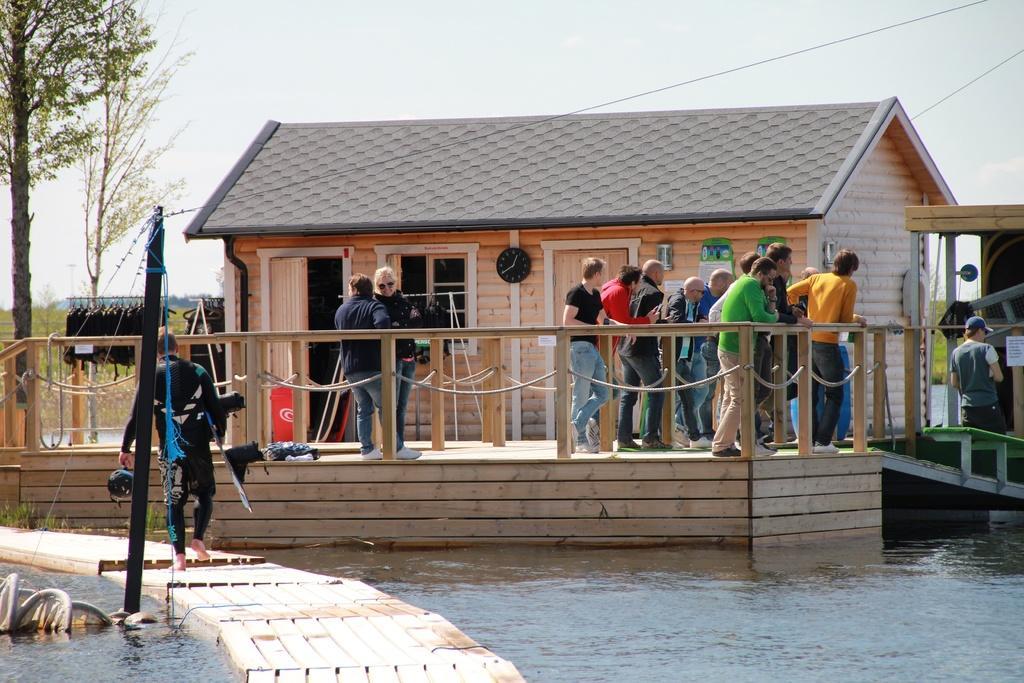Could you give a brief overview of what you see in this image? In this picture we can see a man walking on the wooden surface, pole, water, ropes, fences, house, clock, posters, clothes, trees, some objects and a group of people standing on the floor. In the background we can see the grass and the sky. 